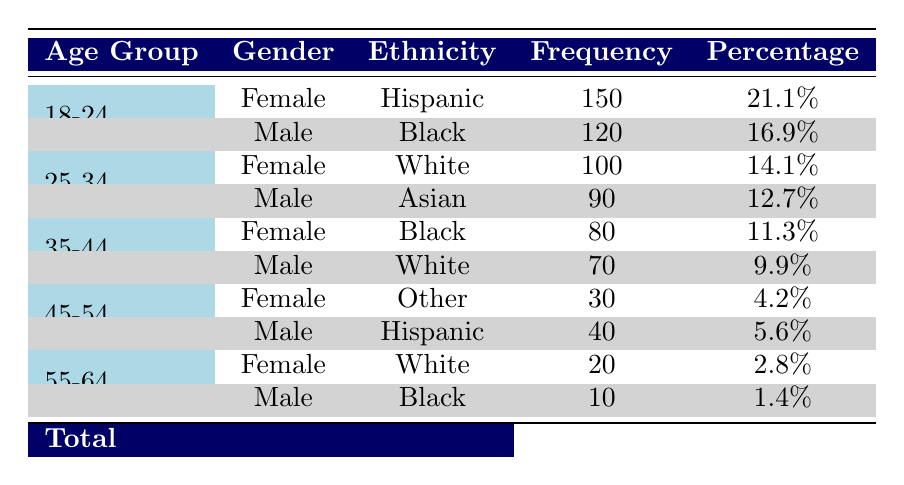What is the frequency of female individuals aged 18-24? The table indicates that there are 150 female individuals in the age group of 18-24. This value is found directly under the frequency column associated with the 18-24 age group and female gender.
Answer: 150 What is the total frequency of male individuals across all age groups? To find the total frequency for male individuals, we sum the frequencies for all male rows: 120 (18-24) + 90 (25-34) + 70 (35-44) + 40 (45-54) + 10 (55-64) = 420.
Answer: 420 Is the frequency of female participants in the age group 25-34 greater than that of male participants in the same age group? The frequency for females in the 25-34 age group is 100, while for males it is 90. Since 100 > 90, the statement is true.
Answer: Yes What is the percentage of participants in the age group 35-44? First, we need to sum the frequencies for the 35-44 age group: 80 (female) + 70 (male) = 150. To find the percentage, we use the total frequency of 710, so (150/710) * 100 = 21.1%.
Answer: 21.1% How many more Hispanic males are there than White males aged 35-44? The frequency of Hispanic males is 40 and the frequency of White males is 70. To find how many more Hispanic males there are, we calculate 40 - 70 = -30. This indicates there are 30 fewer Hispanic males than White males.
Answer: 30 fewer What is the total number of participants aged 55-64? To find this total, we add the frequencies of both genders in the 55-64 age group: 20 (female) + 10 (male) = 30.
Answer: 30 Are there more Black female participants overall than White female participants? The frequencies show that there are 80 Black females (35-44) and 100 White females (25-34 and 55-64 combined). Adding 20 (55-64) gives 120 White females, which is greater than 80 Black females.
Answer: No What is the average frequency of participants from the age group 45-54? For this age group, we have 30 female (Other) and 40 male (Hispanic), giving us a total of 70. To find the average, we divide by 2 (the number of categories within this group): 70 / 2 = 35.
Answer: 35 How many participants fall under the "Other" ethnicity across all age groups? The table shows that there are 30 females classified as "Other" in the 45-54 age group. Therefore, the total is simply 30 as there are no male participants listed under this ethnicity.
Answer: 30 